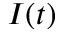<formula> <loc_0><loc_0><loc_500><loc_500>I ( t )</formula> 